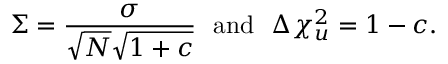<formula> <loc_0><loc_0><loc_500><loc_500>\Sigma = \frac { \sigma } { \sqrt { N } \sqrt { 1 + c } } a n d \Delta { \chi _ { u } ^ { 2 } } = 1 - c .</formula> 